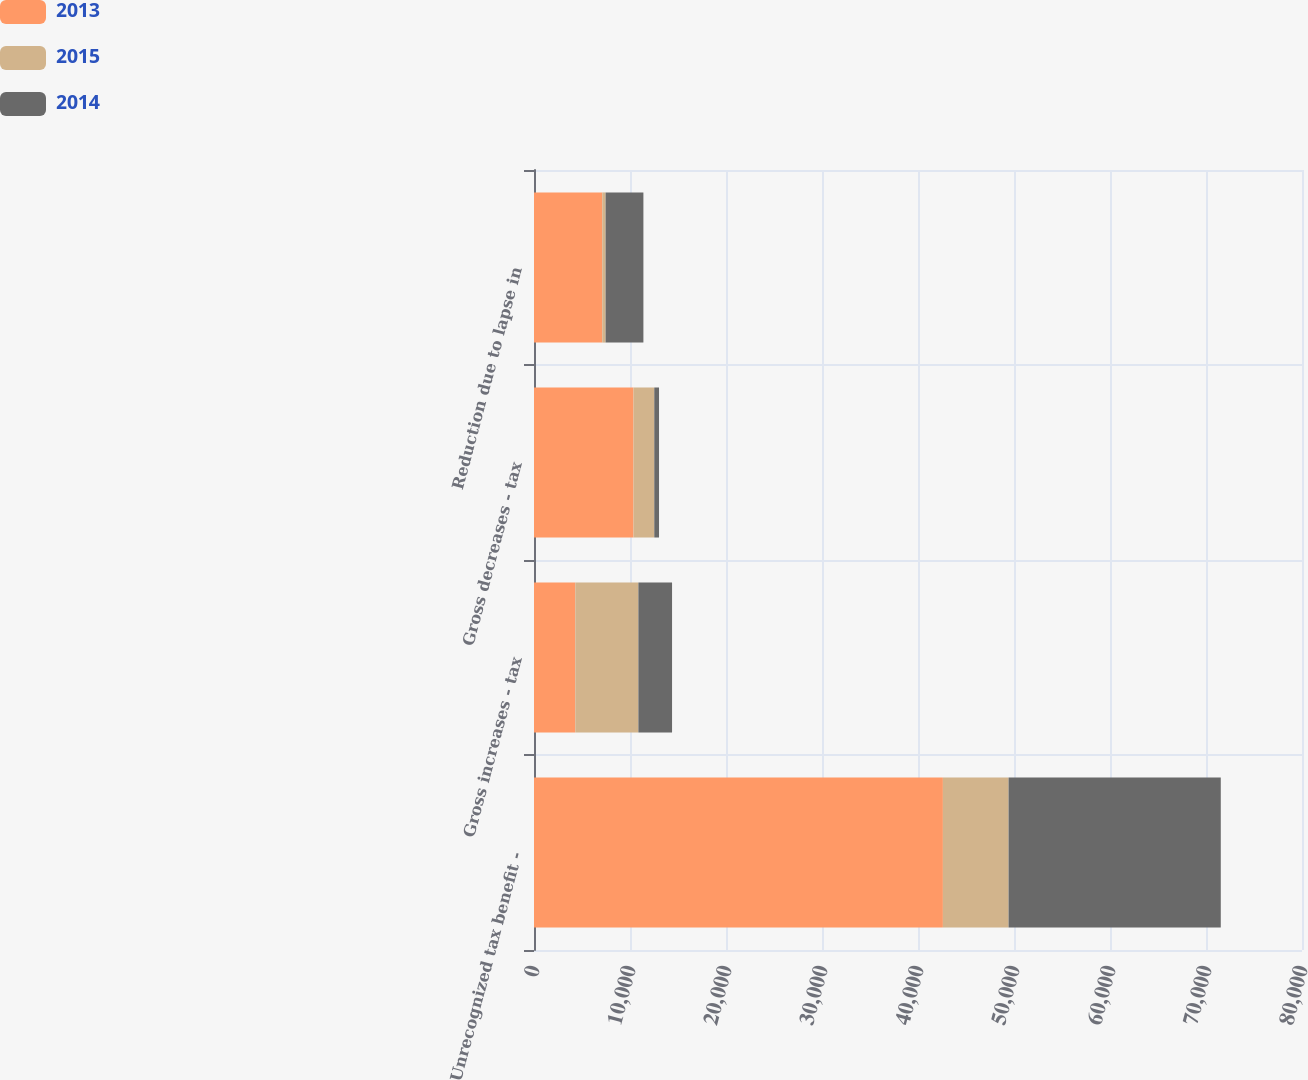<chart> <loc_0><loc_0><loc_500><loc_500><stacked_bar_chart><ecel><fcel>Unrecognized tax benefit -<fcel>Gross increases - tax<fcel>Gross decreases - tax<fcel>Reduction due to lapse in<nl><fcel>2013<fcel>42594<fcel>4305<fcel>10365<fcel>7113<nl><fcel>2015<fcel>6841<fcel>6569<fcel>2164<fcel>346<nl><fcel>2014<fcel>22104<fcel>3507<fcel>495<fcel>3937<nl></chart> 